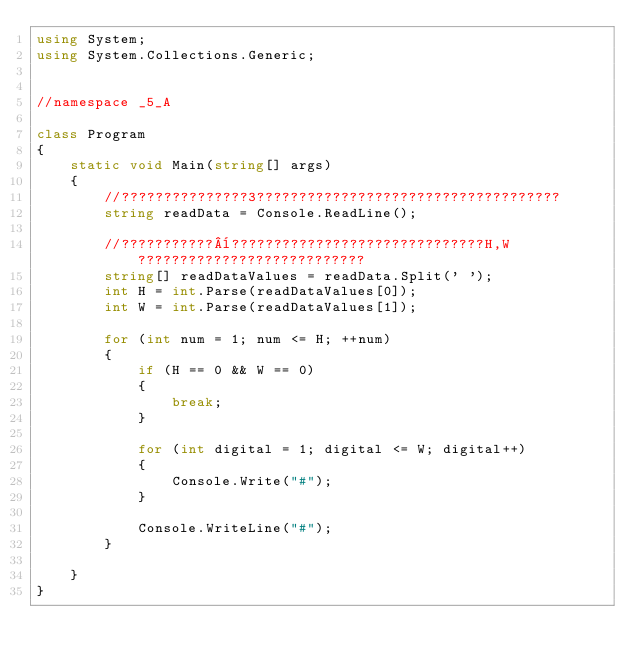Convert code to text. <code><loc_0><loc_0><loc_500><loc_500><_C#_>using System;
using System.Collections.Generic;


//namespace _5_A

class Program
{
    static void Main(string[] args)
    {
        //???????????????3????????????????????????????????????
        string readData = Console.ReadLine();

        //???????????¨??????????????????????????????H,W???????????????????????????
        string[] readDataValues = readData.Split(' ');
        int H = int.Parse(readDataValues[0]);
        int W = int.Parse(readDataValues[1]);

        for (int num = 1; num <= H; ++num)
        {
            if (H == 0 && W == 0)
            {
                break;
            }

            for (int digital = 1; digital <= W; digital++)
            {
                Console.Write("#");
            }

            Console.WriteLine("#");
        }

    }
}</code> 